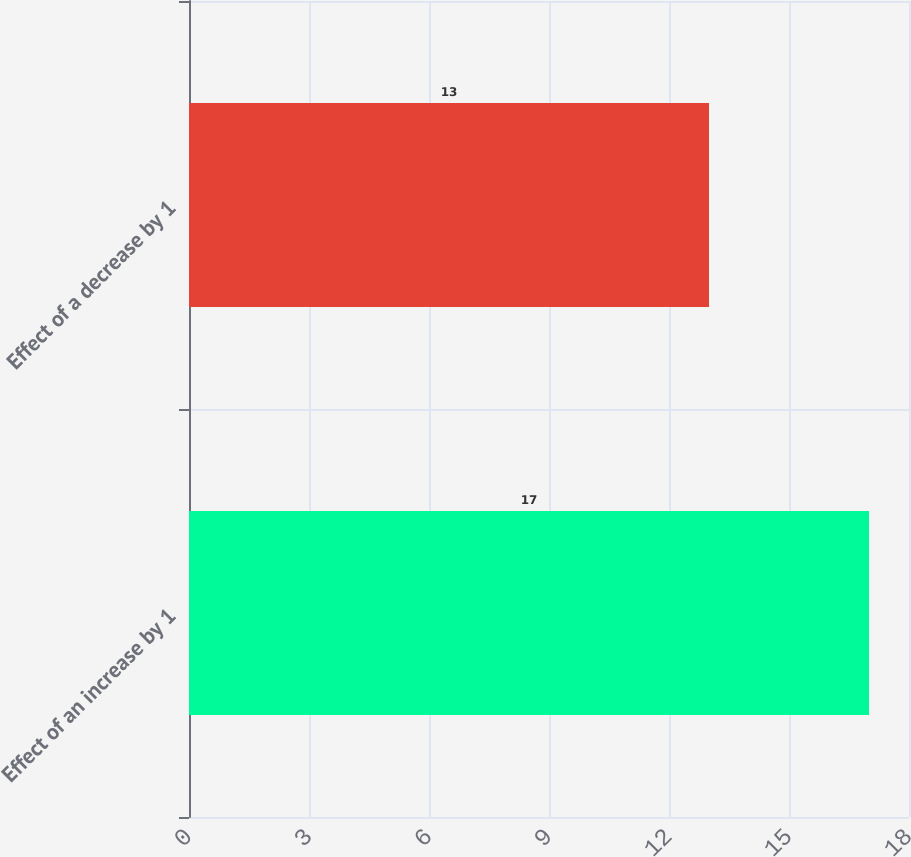<chart> <loc_0><loc_0><loc_500><loc_500><bar_chart><fcel>Effect of an increase by 1<fcel>Effect of a decrease by 1<nl><fcel>17<fcel>13<nl></chart> 